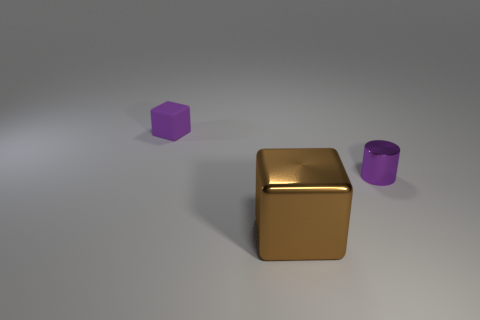Does the metal thing on the right side of the brown metallic thing have the same size as the tiny block?
Your answer should be compact. Yes. There is a cube that is behind the tiny metal thing; what is its size?
Ensure brevity in your answer.  Small. Are there any other things that are the same material as the big brown block?
Provide a succinct answer. Yes. How many red metallic objects are there?
Give a very brief answer. 0. Is the color of the metallic cylinder the same as the small rubber cube?
Provide a short and direct response. Yes. The object that is in front of the purple matte thing and behind the big metallic cube is what color?
Make the answer very short. Purple. There is a tiny purple shiny cylinder; are there any tiny purple metal cylinders in front of it?
Provide a succinct answer. No. How many tiny matte objects are in front of the purple object in front of the small purple matte object?
Your answer should be compact. 0. There is a object that is the same material as the tiny cylinder; what is its size?
Keep it short and to the point. Large. What size is the purple rubber block?
Your answer should be very brief. Small. 